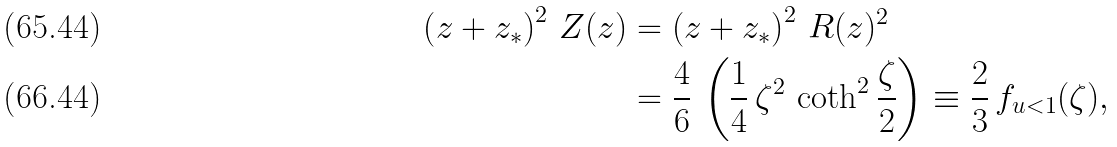<formula> <loc_0><loc_0><loc_500><loc_500>\left ( z + z _ { * } \right ) ^ { 2 } \, Z ( z ) & = \left ( z + z _ { * } \right ) ^ { 2 } \, R ( z ) ^ { 2 } \\ & = \frac { 4 } { 6 } \, \left ( \frac { 1 } { 4 } \, \zeta ^ { 2 } \, \coth ^ { 2 } \frac { \zeta } { 2 } \right ) \equiv \frac { 2 } { 3 } \, f _ { u < 1 } ( \zeta ) ,</formula> 